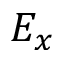<formula> <loc_0><loc_0><loc_500><loc_500>E _ { x }</formula> 